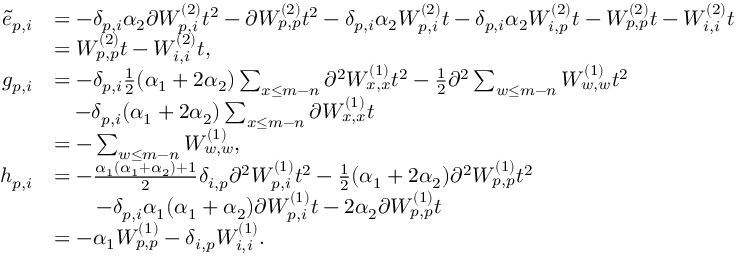<formula> <loc_0><loc_0><loc_500><loc_500>\begin{array} { r l } { \tilde { e } _ { p , i } } & { = - \delta _ { p , i } \alpha _ { 2 } \partial W _ { p , i } ^ { ( 2 ) } t ^ { 2 } - \partial W _ { p , p } ^ { ( 2 ) } t ^ { 2 } - \delta _ { p , i } \alpha _ { 2 } W _ { p , i } ^ { ( 2 ) } t - \delta _ { p , i } \alpha _ { 2 } W _ { i , p } ^ { ( 2 ) } t - W _ { p , p } ^ { ( 2 ) } t - W _ { i , i } ^ { ( 2 ) } t } \\ & { = W _ { p , p } ^ { ( 2 ) } t - W _ { i , i } ^ { ( 2 ) } t , } \\ { g _ { p , i } } & { = - \delta _ { p , i } \frac { 1 } { 2 } ( \alpha _ { 1 } + 2 \alpha _ { 2 } ) \sum _ { x \leq m - n } \partial ^ { 2 } W _ { x , x } ^ { ( 1 ) } t ^ { 2 } - \frac { 1 } { 2 } \partial ^ { 2 } \sum _ { w \leq m - n } W _ { w , w } ^ { ( 1 ) } t ^ { 2 } } \\ & { \quad - \delta _ { p , i } ( \alpha _ { 1 } + 2 \alpha _ { 2 } ) \sum _ { x \leq m - n } \partial W _ { x , x } ^ { ( 1 ) } t } \\ & { = - \sum _ { w \leq m - n } W _ { w , w } ^ { ( 1 ) } , } \\ { h _ { p , i } } & { = - \frac { \alpha _ { 1 } ( \alpha _ { 1 } + \alpha _ { 2 } ) + 1 } { 2 } \delta _ { i , p } \partial ^ { 2 } W _ { p , i } ^ { ( 1 ) } t ^ { 2 } - \frac { 1 } { 2 } ( \alpha _ { 1 } + 2 \alpha _ { 2 } ) \partial ^ { 2 } W _ { p , p } ^ { ( 1 ) } t ^ { 2 } } \\ & { \quad - \delta _ { p , i } \alpha _ { 1 } ( \alpha _ { 1 } + \alpha _ { 2 } ) \partial W _ { p , i } ^ { ( 1 ) } t - 2 \alpha _ { 2 } \partial W _ { p , p } ^ { ( 1 ) } t } \\ & { = - \alpha _ { 1 } W _ { p , p } ^ { ( 1 ) } - \delta _ { i , p } W _ { i , i } ^ { ( 1 ) } . } \end{array}</formula> 